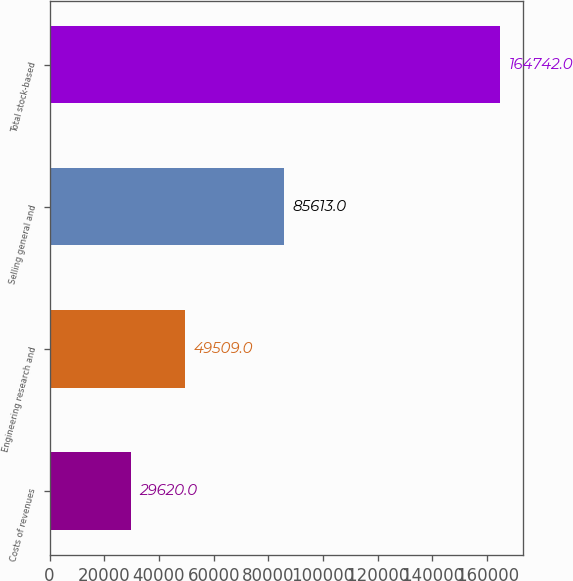<chart> <loc_0><loc_0><loc_500><loc_500><bar_chart><fcel>Costs of revenues<fcel>Engineering research and<fcel>Selling general and<fcel>Total stock-based<nl><fcel>29620<fcel>49509<fcel>85613<fcel>164742<nl></chart> 